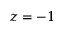Convert formula to latex. <formula><loc_0><loc_0><loc_500><loc_500>z = - 1</formula> 